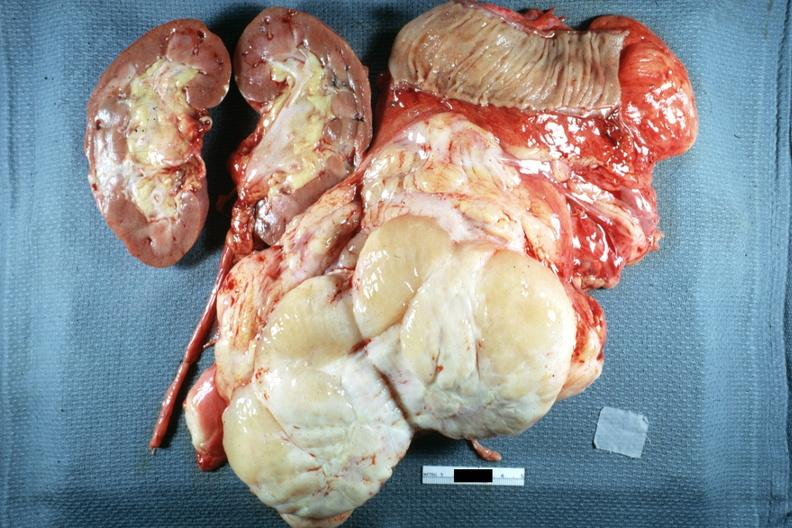what does whole tumor with kidney and portion of jejunum resected surgically cut surface show?
Answer the question using a single word or phrase. Typical fish flesh yellow sarcoma 